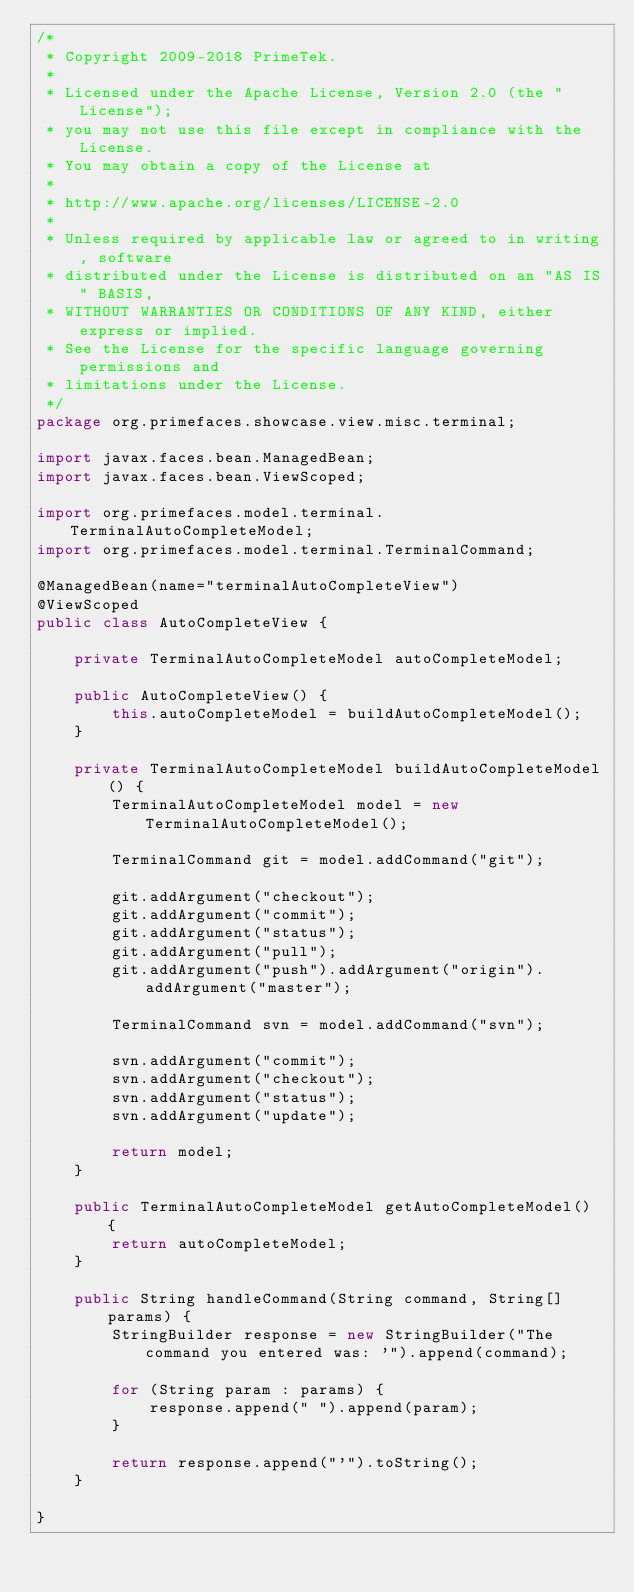Convert code to text. <code><loc_0><loc_0><loc_500><loc_500><_Java_>/*
 * Copyright 2009-2018 PrimeTek.
 *
 * Licensed under the Apache License, Version 2.0 (the "License");
 * you may not use this file except in compliance with the License.
 * You may obtain a copy of the License at
 *
 * http://www.apache.org/licenses/LICENSE-2.0
 *
 * Unless required by applicable law or agreed to in writing, software
 * distributed under the License is distributed on an "AS IS" BASIS,
 * WITHOUT WARRANTIES OR CONDITIONS OF ANY KIND, either express or implied.
 * See the License for the specific language governing permissions and
 * limitations under the License.
 */
package org.primefaces.showcase.view.misc.terminal;

import javax.faces.bean.ManagedBean;
import javax.faces.bean.ViewScoped;

import org.primefaces.model.terminal.TerminalAutoCompleteModel;
import org.primefaces.model.terminal.TerminalCommand;

@ManagedBean(name="terminalAutoCompleteView")
@ViewScoped
public class AutoCompleteView {
    
    private TerminalAutoCompleteModel autoCompleteModel;

    public AutoCompleteView() {
        this.autoCompleteModel = buildAutoCompleteModel();
    }
    
    private TerminalAutoCompleteModel buildAutoCompleteModel() {
        TerminalAutoCompleteModel model = new TerminalAutoCompleteModel();

        TerminalCommand git = model.addCommand("git");
        
        git.addArgument("checkout");
        git.addArgument("commit");
        git.addArgument("status");
        git.addArgument("pull");
        git.addArgument("push").addArgument("origin").addArgument("master");
        
        TerminalCommand svn = model.addCommand("svn");
        
        svn.addArgument("commit");
        svn.addArgument("checkout");
        svn.addArgument("status");
        svn.addArgument("update");
        
        return model;
    }

    public TerminalAutoCompleteModel getAutoCompleteModel() {
        return autoCompleteModel;
    }

    public String handleCommand(String command, String[] params) {
        StringBuilder response = new StringBuilder("The command you entered was: '").append(command);
        
        for (String param : params) {
            response.append(" ").append(param);
        }
        
        return response.append("'").toString();
    }
    
}
</code> 